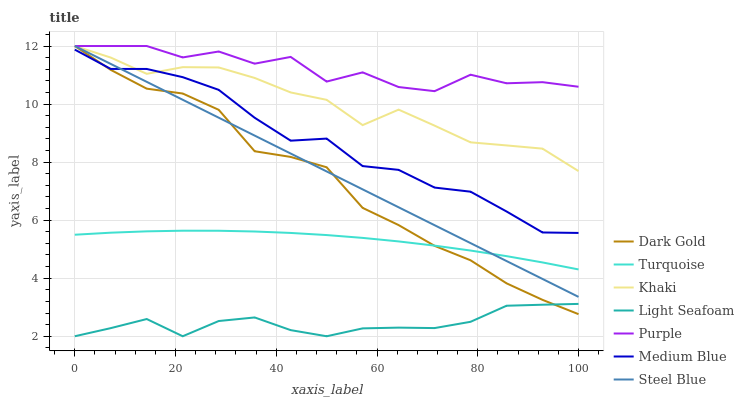Does Light Seafoam have the minimum area under the curve?
Answer yes or no. Yes. Does Purple have the maximum area under the curve?
Answer yes or no. Yes. Does Khaki have the minimum area under the curve?
Answer yes or no. No. Does Khaki have the maximum area under the curve?
Answer yes or no. No. Is Steel Blue the smoothest?
Answer yes or no. Yes. Is Purple the roughest?
Answer yes or no. Yes. Is Khaki the smoothest?
Answer yes or no. No. Is Khaki the roughest?
Answer yes or no. No. Does Light Seafoam have the lowest value?
Answer yes or no. Yes. Does Khaki have the lowest value?
Answer yes or no. No. Does Steel Blue have the highest value?
Answer yes or no. Yes. Does Medium Blue have the highest value?
Answer yes or no. No. Is Light Seafoam less than Purple?
Answer yes or no. Yes. Is Medium Blue greater than Light Seafoam?
Answer yes or no. Yes. Does Steel Blue intersect Khaki?
Answer yes or no. Yes. Is Steel Blue less than Khaki?
Answer yes or no. No. Is Steel Blue greater than Khaki?
Answer yes or no. No. Does Light Seafoam intersect Purple?
Answer yes or no. No. 